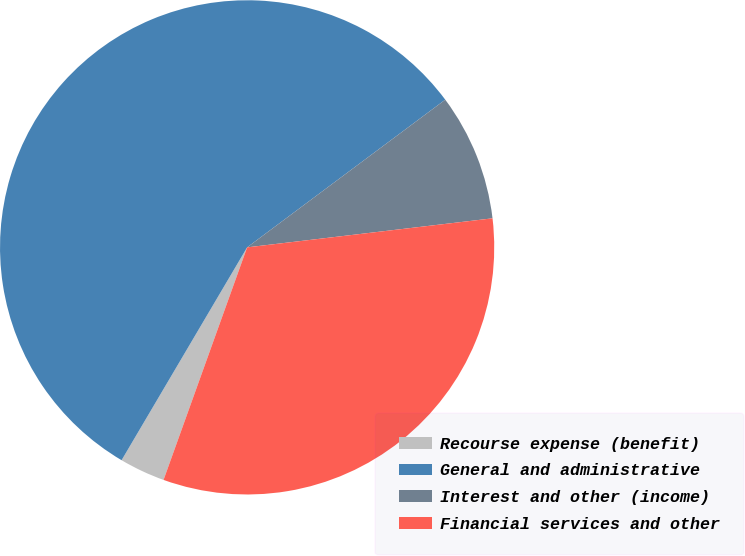<chart> <loc_0><loc_0><loc_500><loc_500><pie_chart><fcel>Recourse expense (benefit)<fcel>General and administrative<fcel>Interest and other (income)<fcel>Financial services and other<nl><fcel>2.99%<fcel>56.33%<fcel>8.32%<fcel>32.37%<nl></chart> 